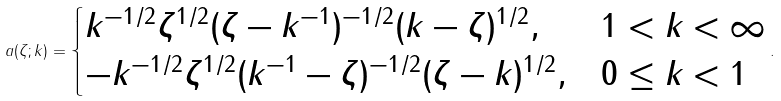<formula> <loc_0><loc_0><loc_500><loc_500>a ( \zeta ; k ) = \begin{cases} k ^ { - 1 / 2 } \zeta ^ { 1 / 2 } ( \zeta - k ^ { - 1 } ) ^ { - 1 / 2 } ( k - \zeta ) ^ { 1 / 2 } , & 1 < k < \infty \\ - k ^ { - 1 / 2 } \zeta ^ { 1 / 2 } ( k ^ { - 1 } - \zeta ) ^ { - 1 / 2 } ( \zeta - k ) ^ { 1 / 2 } , & 0 \leq k < 1 \end{cases} .</formula> 